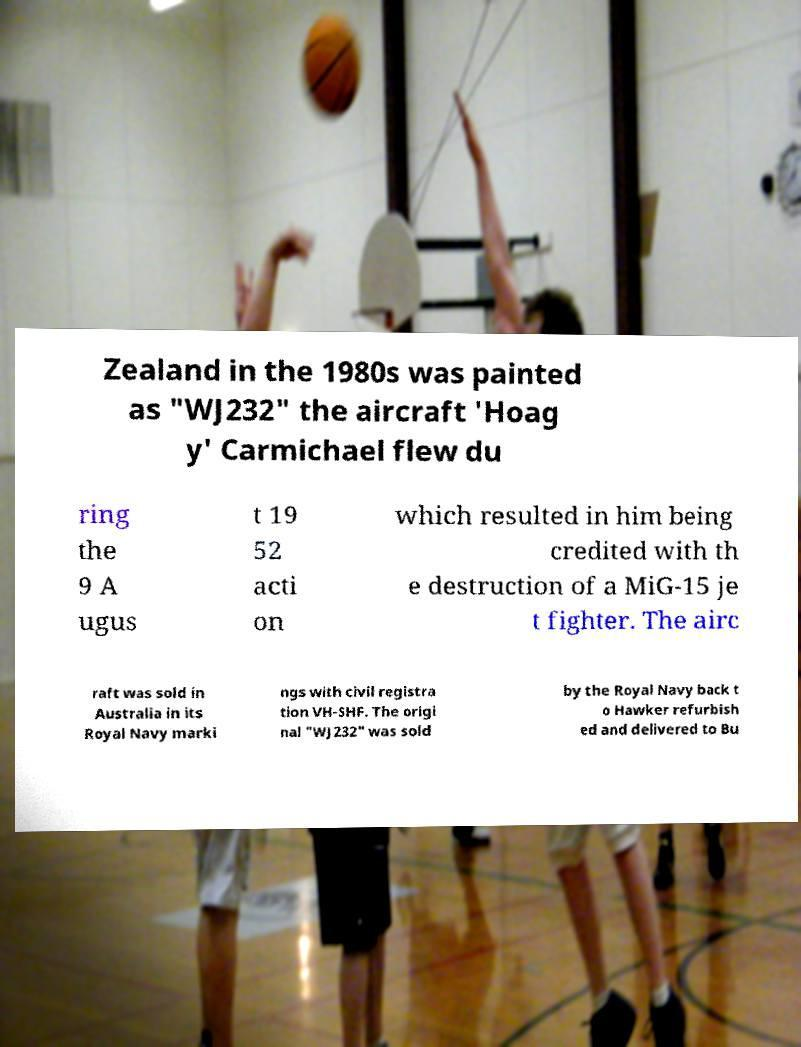For documentation purposes, I need the text within this image transcribed. Could you provide that? Zealand in the 1980s was painted as "WJ232" the aircraft 'Hoag y' Carmichael flew du ring the 9 A ugus t 19 52 acti on which resulted in him being credited with th e destruction of a MiG-15 je t fighter. The airc raft was sold in Australia in its Royal Navy marki ngs with civil registra tion VH-SHF. The origi nal "WJ232" was sold by the Royal Navy back t o Hawker refurbish ed and delivered to Bu 